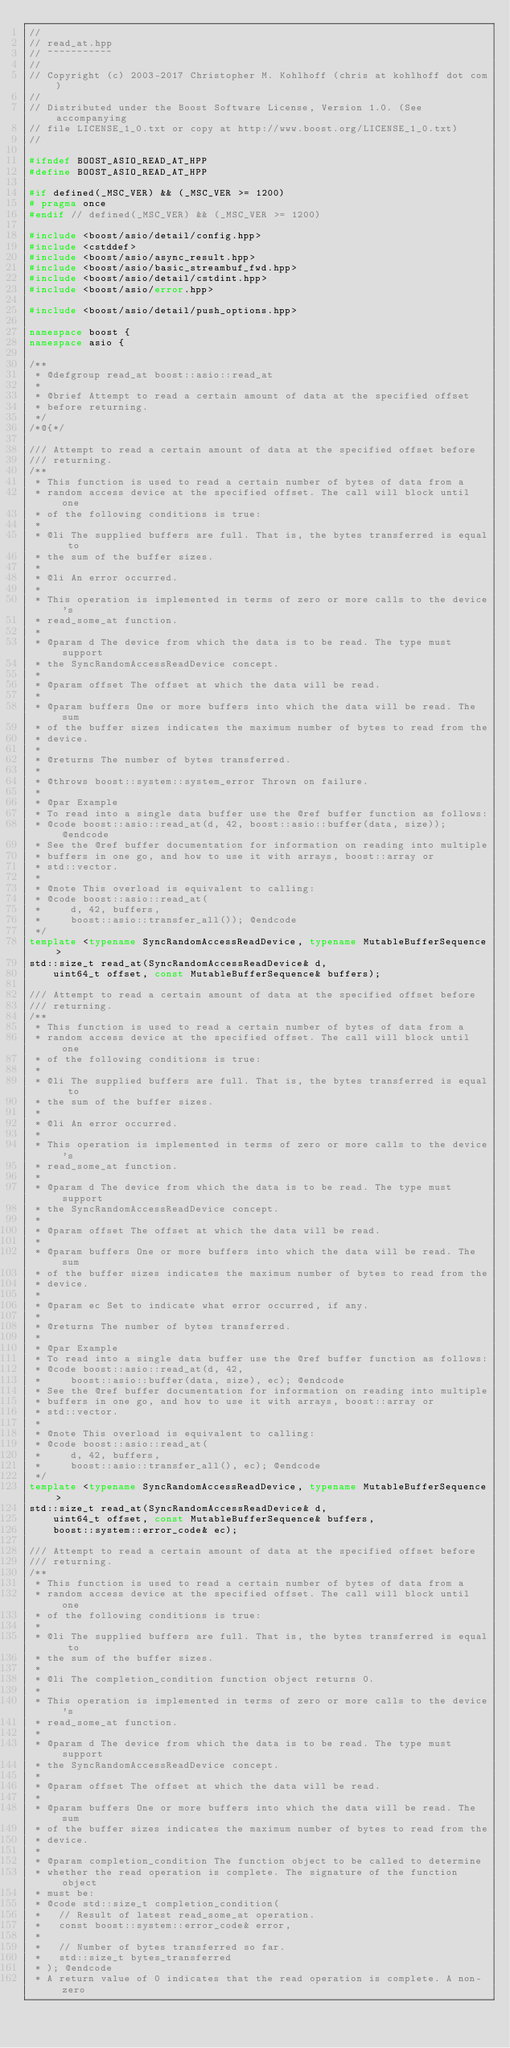<code> <loc_0><loc_0><loc_500><loc_500><_C++_>//
// read_at.hpp
// ~~~~~~~~~~~
//
// Copyright (c) 2003-2017 Christopher M. Kohlhoff (chris at kohlhoff dot com)
//
// Distributed under the Boost Software License, Version 1.0. (See accompanying
// file LICENSE_1_0.txt or copy at http://www.boost.org/LICENSE_1_0.txt)
//

#ifndef BOOST_ASIO_READ_AT_HPP
#define BOOST_ASIO_READ_AT_HPP

#if defined(_MSC_VER) && (_MSC_VER >= 1200)
# pragma once
#endif // defined(_MSC_VER) && (_MSC_VER >= 1200)

#include <boost/asio/detail/config.hpp>
#include <cstddef>
#include <boost/asio/async_result.hpp>
#include <boost/asio/basic_streambuf_fwd.hpp>
#include <boost/asio/detail/cstdint.hpp>
#include <boost/asio/error.hpp>

#include <boost/asio/detail/push_options.hpp>

namespace boost {
namespace asio {

/**
 * @defgroup read_at boost::asio::read_at
 *
 * @brief Attempt to read a certain amount of data at the specified offset
 * before returning.
 */
/*@{*/

/// Attempt to read a certain amount of data at the specified offset before
/// returning.
/**
 * This function is used to read a certain number of bytes of data from a
 * random access device at the specified offset. The call will block until one
 * of the following conditions is true:
 *
 * @li The supplied buffers are full. That is, the bytes transferred is equal to
 * the sum of the buffer sizes.
 *
 * @li An error occurred.
 *
 * This operation is implemented in terms of zero or more calls to the device's
 * read_some_at function.
 *
 * @param d The device from which the data is to be read. The type must support
 * the SyncRandomAccessReadDevice concept.
 *
 * @param offset The offset at which the data will be read.
 *
 * @param buffers One or more buffers into which the data will be read. The sum
 * of the buffer sizes indicates the maximum number of bytes to read from the
 * device.
 *
 * @returns The number of bytes transferred.
 *
 * @throws boost::system::system_error Thrown on failure.
 *
 * @par Example
 * To read into a single data buffer use the @ref buffer function as follows:
 * @code boost::asio::read_at(d, 42, boost::asio::buffer(data, size)); @endcode
 * See the @ref buffer documentation for information on reading into multiple
 * buffers in one go, and how to use it with arrays, boost::array or
 * std::vector.
 *
 * @note This overload is equivalent to calling:
 * @code boost::asio::read_at(
 *     d, 42, buffers,
 *     boost::asio::transfer_all()); @endcode
 */
template <typename SyncRandomAccessReadDevice, typename MutableBufferSequence>
std::size_t read_at(SyncRandomAccessReadDevice& d,
    uint64_t offset, const MutableBufferSequence& buffers);

/// Attempt to read a certain amount of data at the specified offset before
/// returning.
/**
 * This function is used to read a certain number of bytes of data from a
 * random access device at the specified offset. The call will block until one
 * of the following conditions is true:
 *
 * @li The supplied buffers are full. That is, the bytes transferred is equal to
 * the sum of the buffer sizes.
 *
 * @li An error occurred.
 *
 * This operation is implemented in terms of zero or more calls to the device's
 * read_some_at function.
 *
 * @param d The device from which the data is to be read. The type must support
 * the SyncRandomAccessReadDevice concept.
 *
 * @param offset The offset at which the data will be read.
 *
 * @param buffers One or more buffers into which the data will be read. The sum
 * of the buffer sizes indicates the maximum number of bytes to read from the
 * device.
 *
 * @param ec Set to indicate what error occurred, if any.
 *
 * @returns The number of bytes transferred.
 *
 * @par Example
 * To read into a single data buffer use the @ref buffer function as follows:
 * @code boost::asio::read_at(d, 42,
 *     boost::asio::buffer(data, size), ec); @endcode
 * See the @ref buffer documentation for information on reading into multiple
 * buffers in one go, and how to use it with arrays, boost::array or
 * std::vector.
 *
 * @note This overload is equivalent to calling:
 * @code boost::asio::read_at(
 *     d, 42, buffers,
 *     boost::asio::transfer_all(), ec); @endcode
 */
template <typename SyncRandomAccessReadDevice, typename MutableBufferSequence>
std::size_t read_at(SyncRandomAccessReadDevice& d,
    uint64_t offset, const MutableBufferSequence& buffers,
    boost::system::error_code& ec);

/// Attempt to read a certain amount of data at the specified offset before
/// returning.
/**
 * This function is used to read a certain number of bytes of data from a
 * random access device at the specified offset. The call will block until one
 * of the following conditions is true:
 *
 * @li The supplied buffers are full. That is, the bytes transferred is equal to
 * the sum of the buffer sizes.
 *
 * @li The completion_condition function object returns 0.
 *
 * This operation is implemented in terms of zero or more calls to the device's
 * read_some_at function.
 *
 * @param d The device from which the data is to be read. The type must support
 * the SyncRandomAccessReadDevice concept.
 *
 * @param offset The offset at which the data will be read.
 *
 * @param buffers One or more buffers into which the data will be read. The sum
 * of the buffer sizes indicates the maximum number of bytes to read from the
 * device.
 *
 * @param completion_condition The function object to be called to determine
 * whether the read operation is complete. The signature of the function object
 * must be:
 * @code std::size_t completion_condition(
 *   // Result of latest read_some_at operation.
 *   const boost::system::error_code& error,
 *
 *   // Number of bytes transferred so far.
 *   std::size_t bytes_transferred
 * ); @endcode
 * A return value of 0 indicates that the read operation is complete. A non-zero</code> 